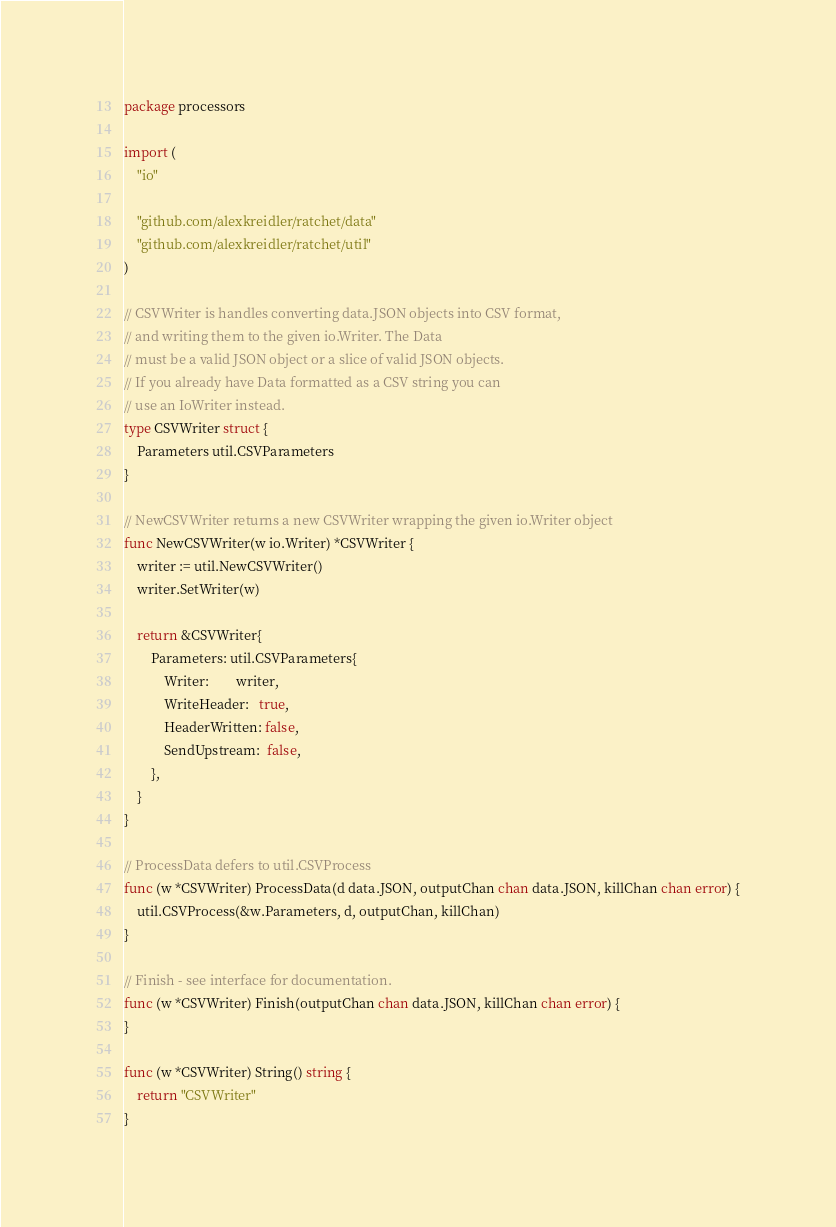Convert code to text. <code><loc_0><loc_0><loc_500><loc_500><_Go_>package processors

import (
	"io"

	"github.com/alexkreidler/ratchet/data"
	"github.com/alexkreidler/ratchet/util"
)

// CSVWriter is handles converting data.JSON objects into CSV format,
// and writing them to the given io.Writer. The Data
// must be a valid JSON object or a slice of valid JSON objects.
// If you already have Data formatted as a CSV string you can
// use an IoWriter instead.
type CSVWriter struct {
	Parameters util.CSVParameters
}

// NewCSVWriter returns a new CSVWriter wrapping the given io.Writer object
func NewCSVWriter(w io.Writer) *CSVWriter {
	writer := util.NewCSVWriter()
	writer.SetWriter(w)

	return &CSVWriter{
		Parameters: util.CSVParameters{
			Writer:        writer,
			WriteHeader:   true,
			HeaderWritten: false,
			SendUpstream:  false,
		},
	}
}

// ProcessData defers to util.CSVProcess
func (w *CSVWriter) ProcessData(d data.JSON, outputChan chan data.JSON, killChan chan error) {
	util.CSVProcess(&w.Parameters, d, outputChan, killChan)
}

// Finish - see interface for documentation.
func (w *CSVWriter) Finish(outputChan chan data.JSON, killChan chan error) {
}

func (w *CSVWriter) String() string {
	return "CSVWriter"
}
</code> 